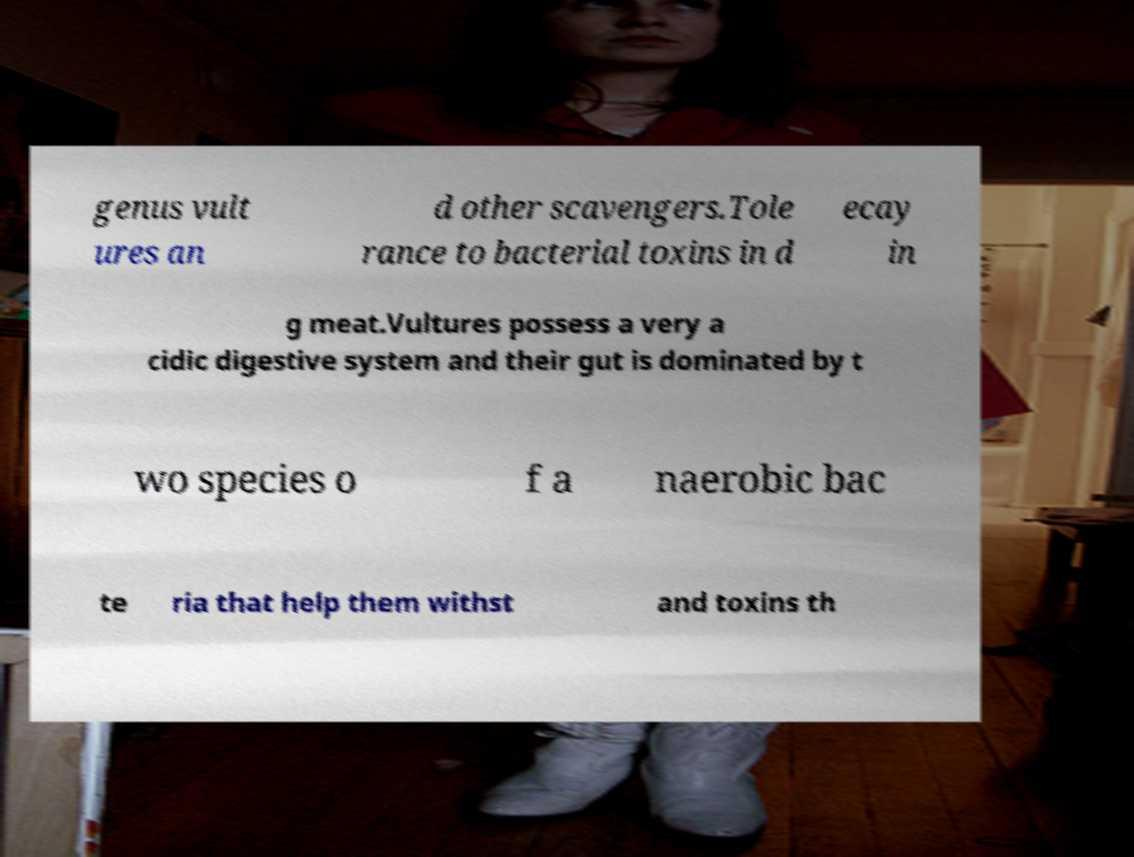For documentation purposes, I need the text within this image transcribed. Could you provide that? genus vult ures an d other scavengers.Tole rance to bacterial toxins in d ecay in g meat.Vultures possess a very a cidic digestive system and their gut is dominated by t wo species o f a naerobic bac te ria that help them withst and toxins th 